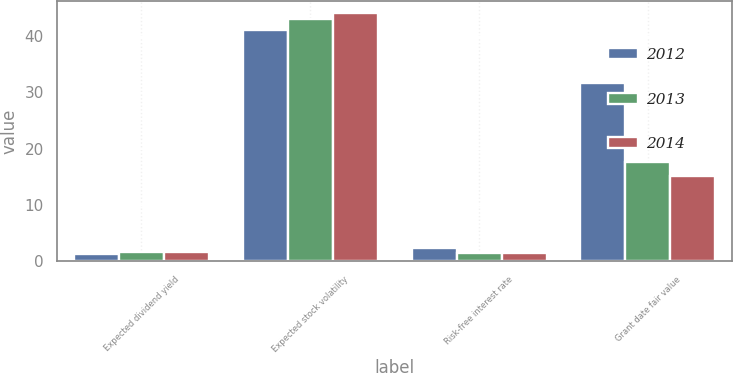Convert chart to OTSL. <chart><loc_0><loc_0><loc_500><loc_500><stacked_bar_chart><ecel><fcel>Expected dividend yield<fcel>Expected stock volatility<fcel>Risk-free interest rate<fcel>Grant date fair value<nl><fcel>2012<fcel>1.41<fcel>41<fcel>2.3<fcel>31.53<nl><fcel>2013<fcel>1.72<fcel>43<fcel>1.53<fcel>17.58<nl><fcel>2014<fcel>1.66<fcel>44<fcel>1.55<fcel>15.19<nl></chart> 